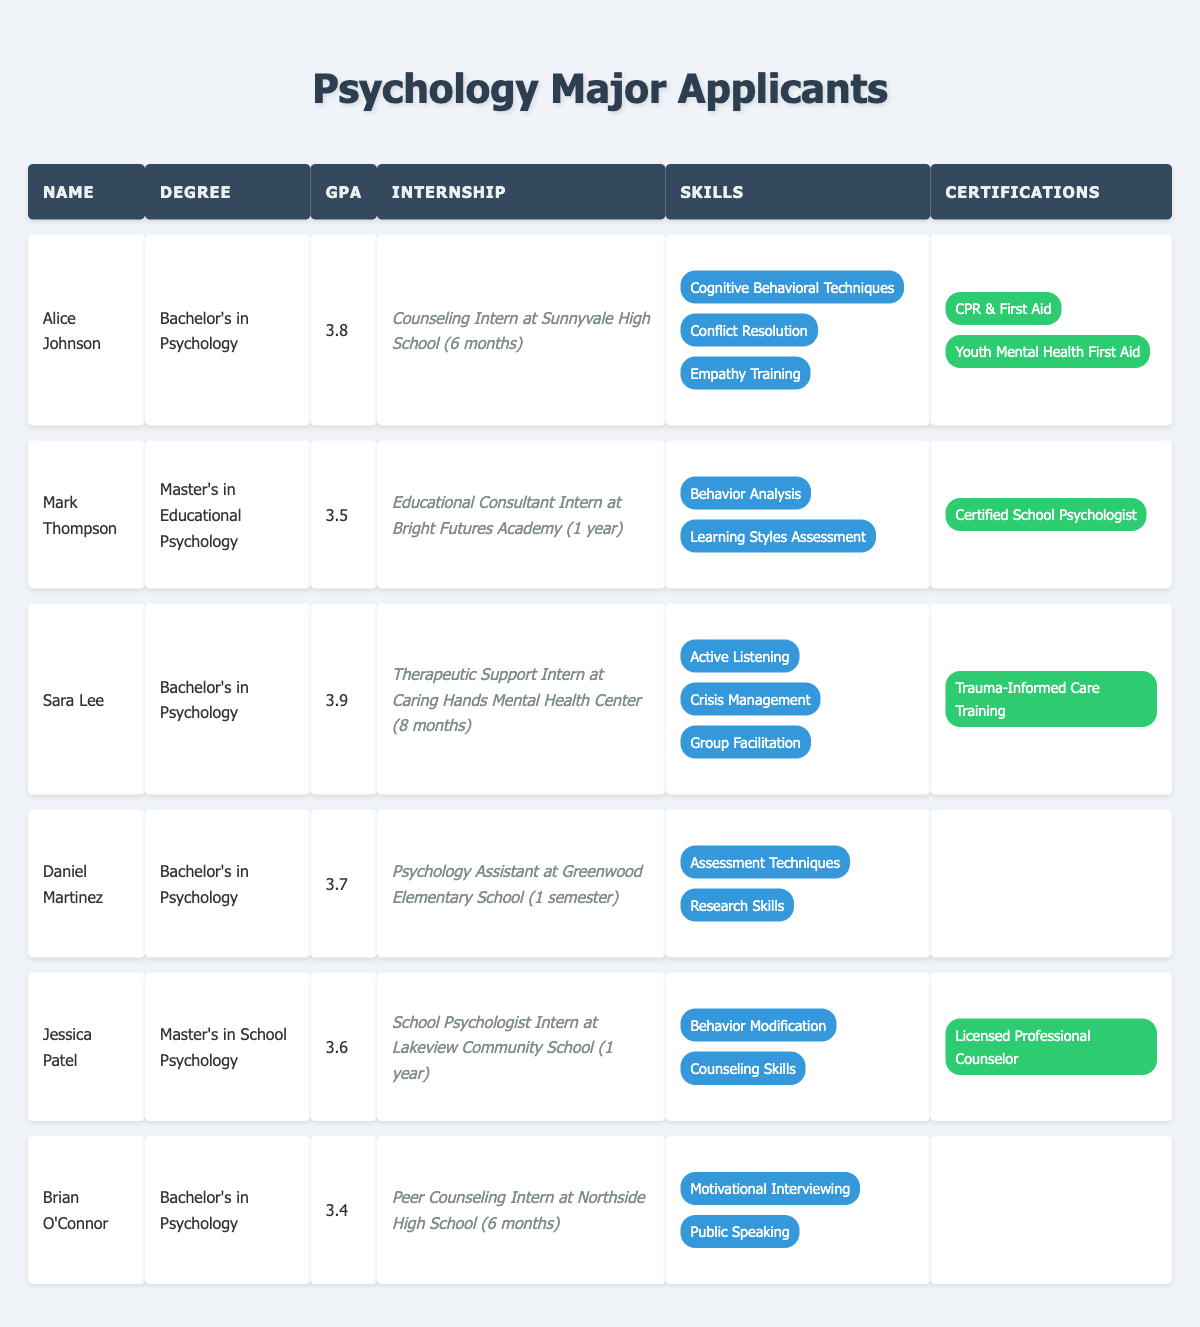What is the highest GPA among the applicants? The GPAs of the applicants are 3.8 (Alice Johnson), 3.5 (Mark Thompson), 3.9 (Sara Lee), 3.7 (Daniel Martinez), 3.6 (Jessica Patel), and 3.4 (Brian O'Connor). The highest GPA is 3.9, which belongs to Sara Lee.
Answer: 3.9 How many applicants have a Bachelor's degree in Psychology? The applicants with a Bachelor's degree in Psychology are Alice Johnson, Sara Lee, Daniel Martinez, and Brian O'Connor. There are 4 applicants with this degree.
Answer: 4 Do any applicants have certifications related to mental health? Yes, Alice Johnson has two certifications: CPR & First Aid and Youth Mental Health First Aid. Sara Lee has Trauma-Informed Care Training. Jessica Patel is a Licensed Professional Counselor.
Answer: Yes Which applicant has the most internships completed? Mark Thompson completed 1 internship, Jessica Patel completed 1 internship, while Alice Johnson, Sara Lee, Daniel Martinez, and Brian O'Connor also completed 1 internship each. Therefore, all applicants listed completed the same number of internships.
Answer: All have 1 internship What is the average GPA of all the applicants? The GPAs are 3.8, 3.5, 3.9, 3.7, 3.6, and 3.4. The sum of these GPAs is 3.8 + 3.5 + 3.9 + 3.7 + 3.6 + 3.4 = 21.9. There are 6 applicants, so the average GPA is 21.9 / 6 = 3.65.
Answer: 3.65 Which applicant has the shortest internship? Daniel Martinez's internship as a Psychology Assistant at Greenwood Elementary School lasted for 1 semester. All others last for 6 months or longer.
Answer: Daniel Martinez How many applicants listed have no certifications? The applicants with no certifications are Daniel Martinez and Brian O'Connor, giving a total of 2 applicants without certifications.
Answer: 2 Who has the most relevant skills for managing crises? Sara Lee has Crisis Management listed among her skills, while no other applicant mentions this specific skill. Therefore, she has the most relevant skill for managing crises.
Answer: Sara Lee If we combine the GPAs of all applicants, what would be the combined total? The combined total of the GPAs is calculated as follows: 3.8 + 3.5 + 3.9 + 3.7 + 3.6 + 3.4 = 21.9
Answer: 21.9 Which applicant has an internship specifically at a mental health center? Sara Lee's internship was at "Caring Hands Mental Health Center," making her the only applicant with an internship specifically at a mental health center.
Answer: Sara Lee Considering only skills related to counseling, which applicants qualify? Alice Johnson and Jessica Patel both have skills related to counseling (Alice with Empathy Training and Jessica with Counseling Skills). Therefore, both qualify on this basis.
Answer: Alice Johnson and Jessica Patel 